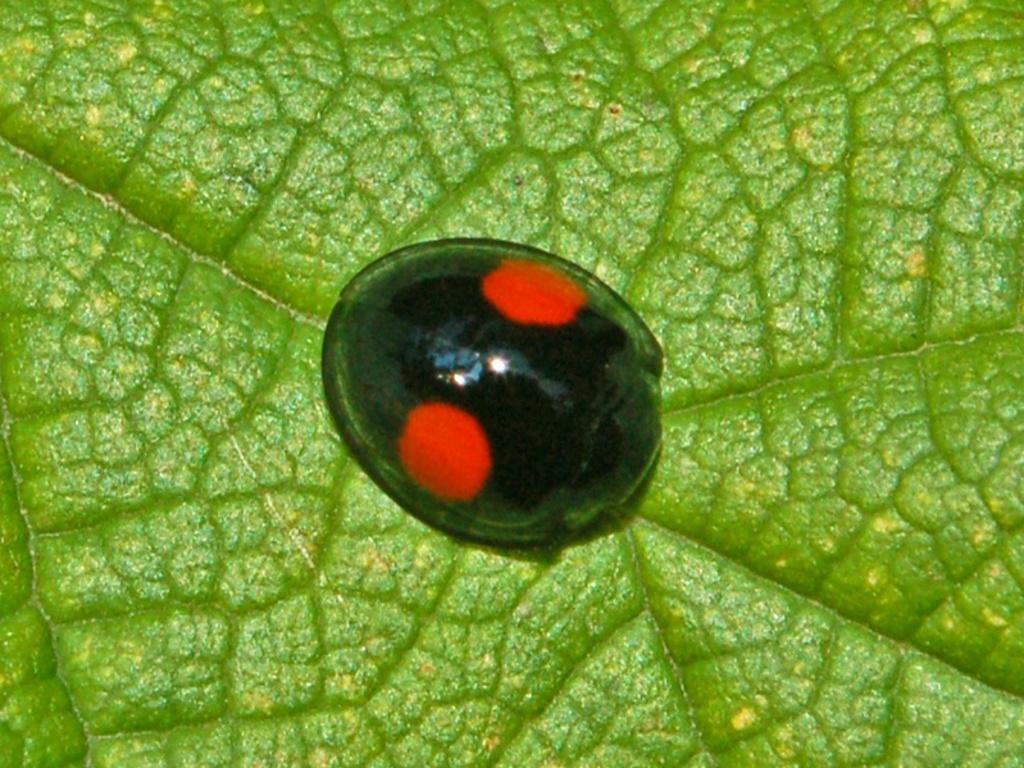Could you give a brief overview of what you see in this image? In this image I can see an insect which is black and red in color on the leaf which is green and yellow in color. 